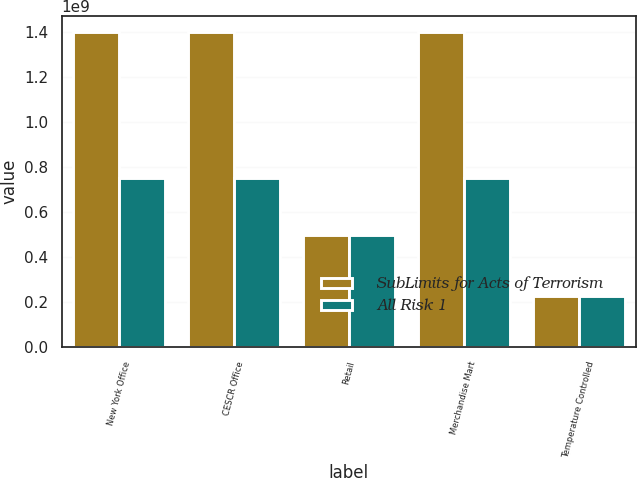Convert chart. <chart><loc_0><loc_0><loc_500><loc_500><stacked_bar_chart><ecel><fcel>New York Office<fcel>CESCR Office<fcel>Retail<fcel>Merchandise Mart<fcel>Temperature Controlled<nl><fcel>SubLimits for Acts of Terrorism<fcel>1.4e+09<fcel>1.4e+09<fcel>5e+08<fcel>1.4e+09<fcel>2.25e+08<nl><fcel>All Risk 1<fcel>7.5e+08<fcel>7.5e+08<fcel>5e+08<fcel>7.5e+08<fcel>2.25e+08<nl></chart> 